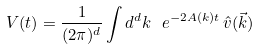Convert formula to latex. <formula><loc_0><loc_0><loc_500><loc_500>V ( t ) = \frac { 1 } { ( 2 \pi ) ^ { d } } \int d ^ { d } k \ e ^ { - 2 A ( k ) t } \, \hat { v } ( \vec { k } )</formula> 